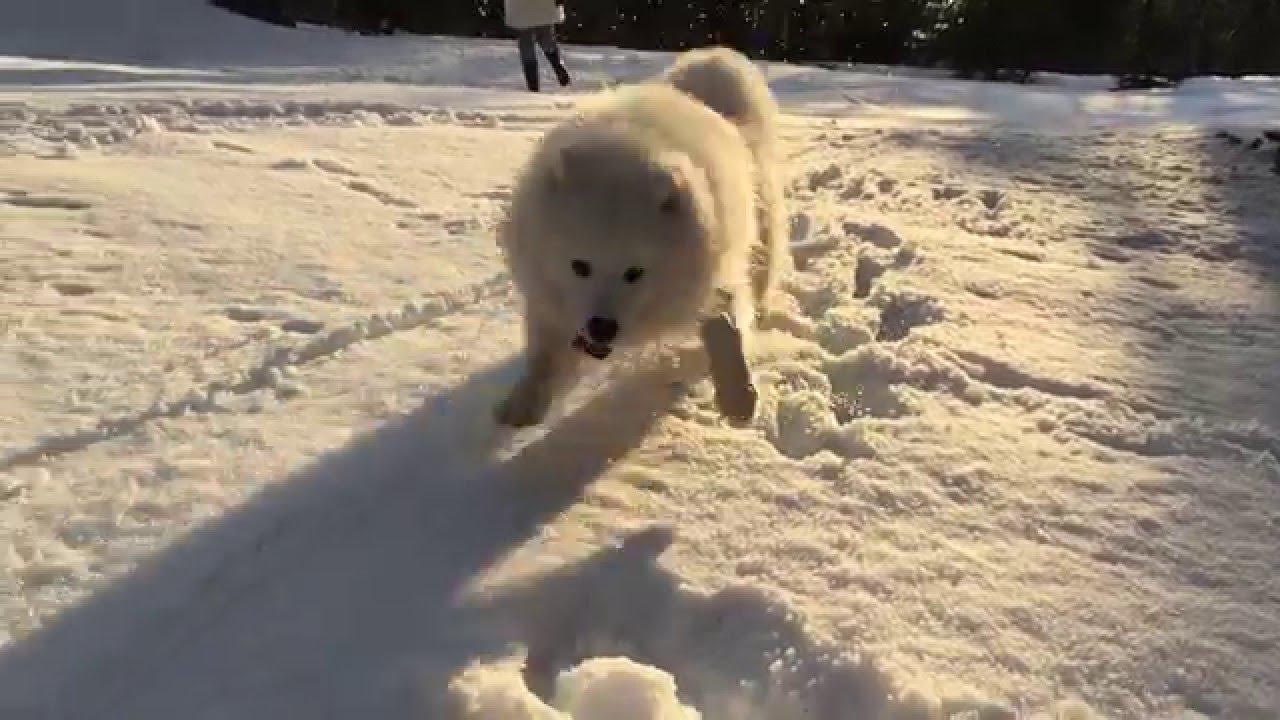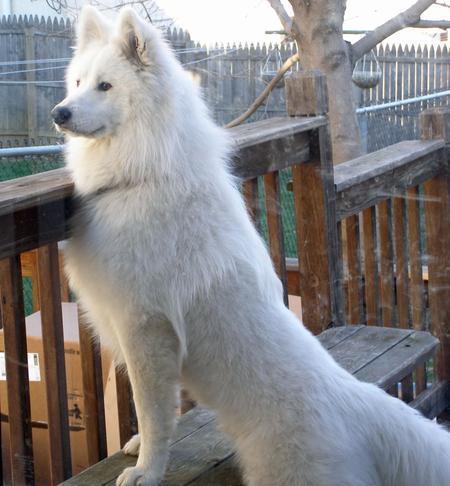The first image is the image on the left, the second image is the image on the right. Assess this claim about the two images: "The left image contains a white dog swimming in water.". Correct or not? Answer yes or no. No. The first image is the image on the left, the second image is the image on the right. Considering the images on both sides, is "In at least one image, a white dog is seen swimming in water" valid? Answer yes or no. No. 